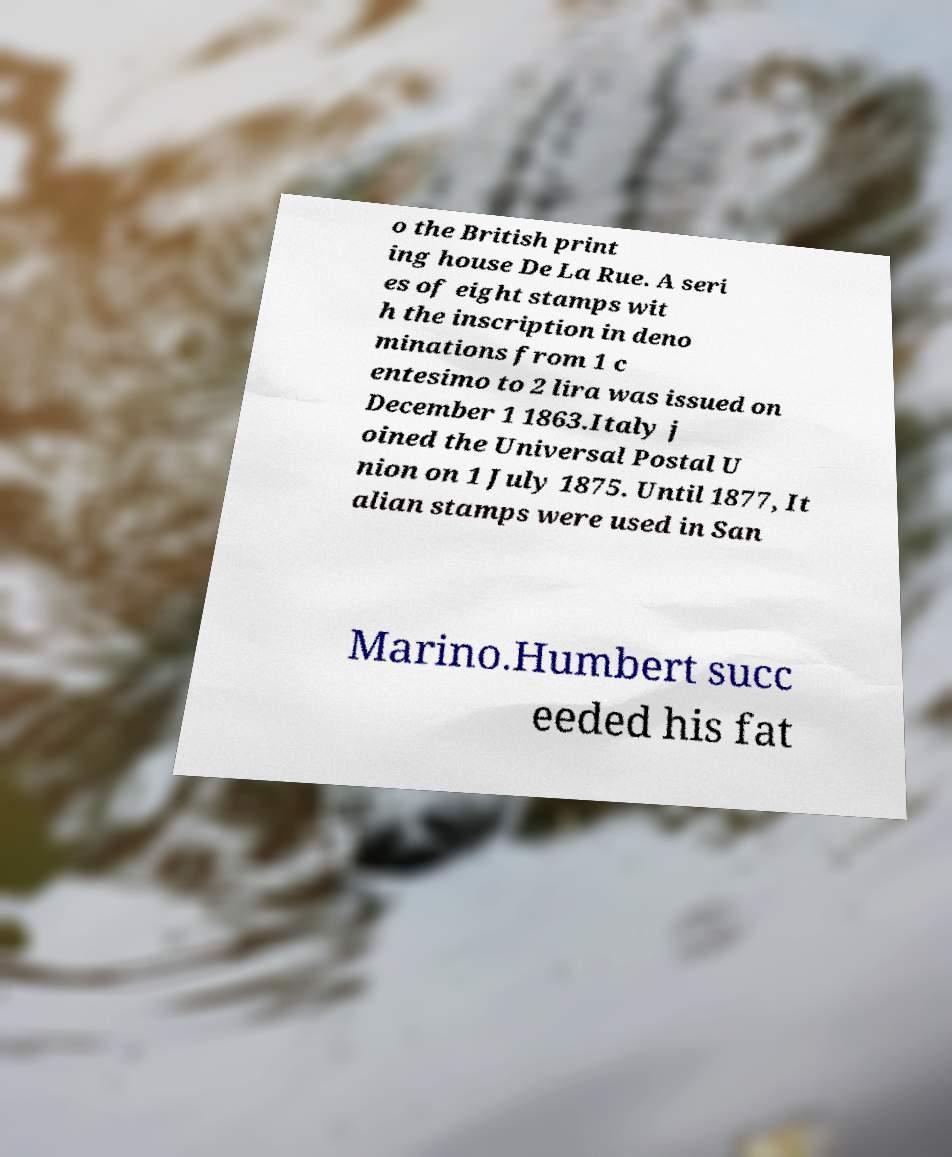Please identify and transcribe the text found in this image. o the British print ing house De La Rue. A seri es of eight stamps wit h the inscription in deno minations from 1 c entesimo to 2 lira was issued on December 1 1863.Italy j oined the Universal Postal U nion on 1 July 1875. Until 1877, It alian stamps were used in San Marino.Humbert succ eeded his fat 